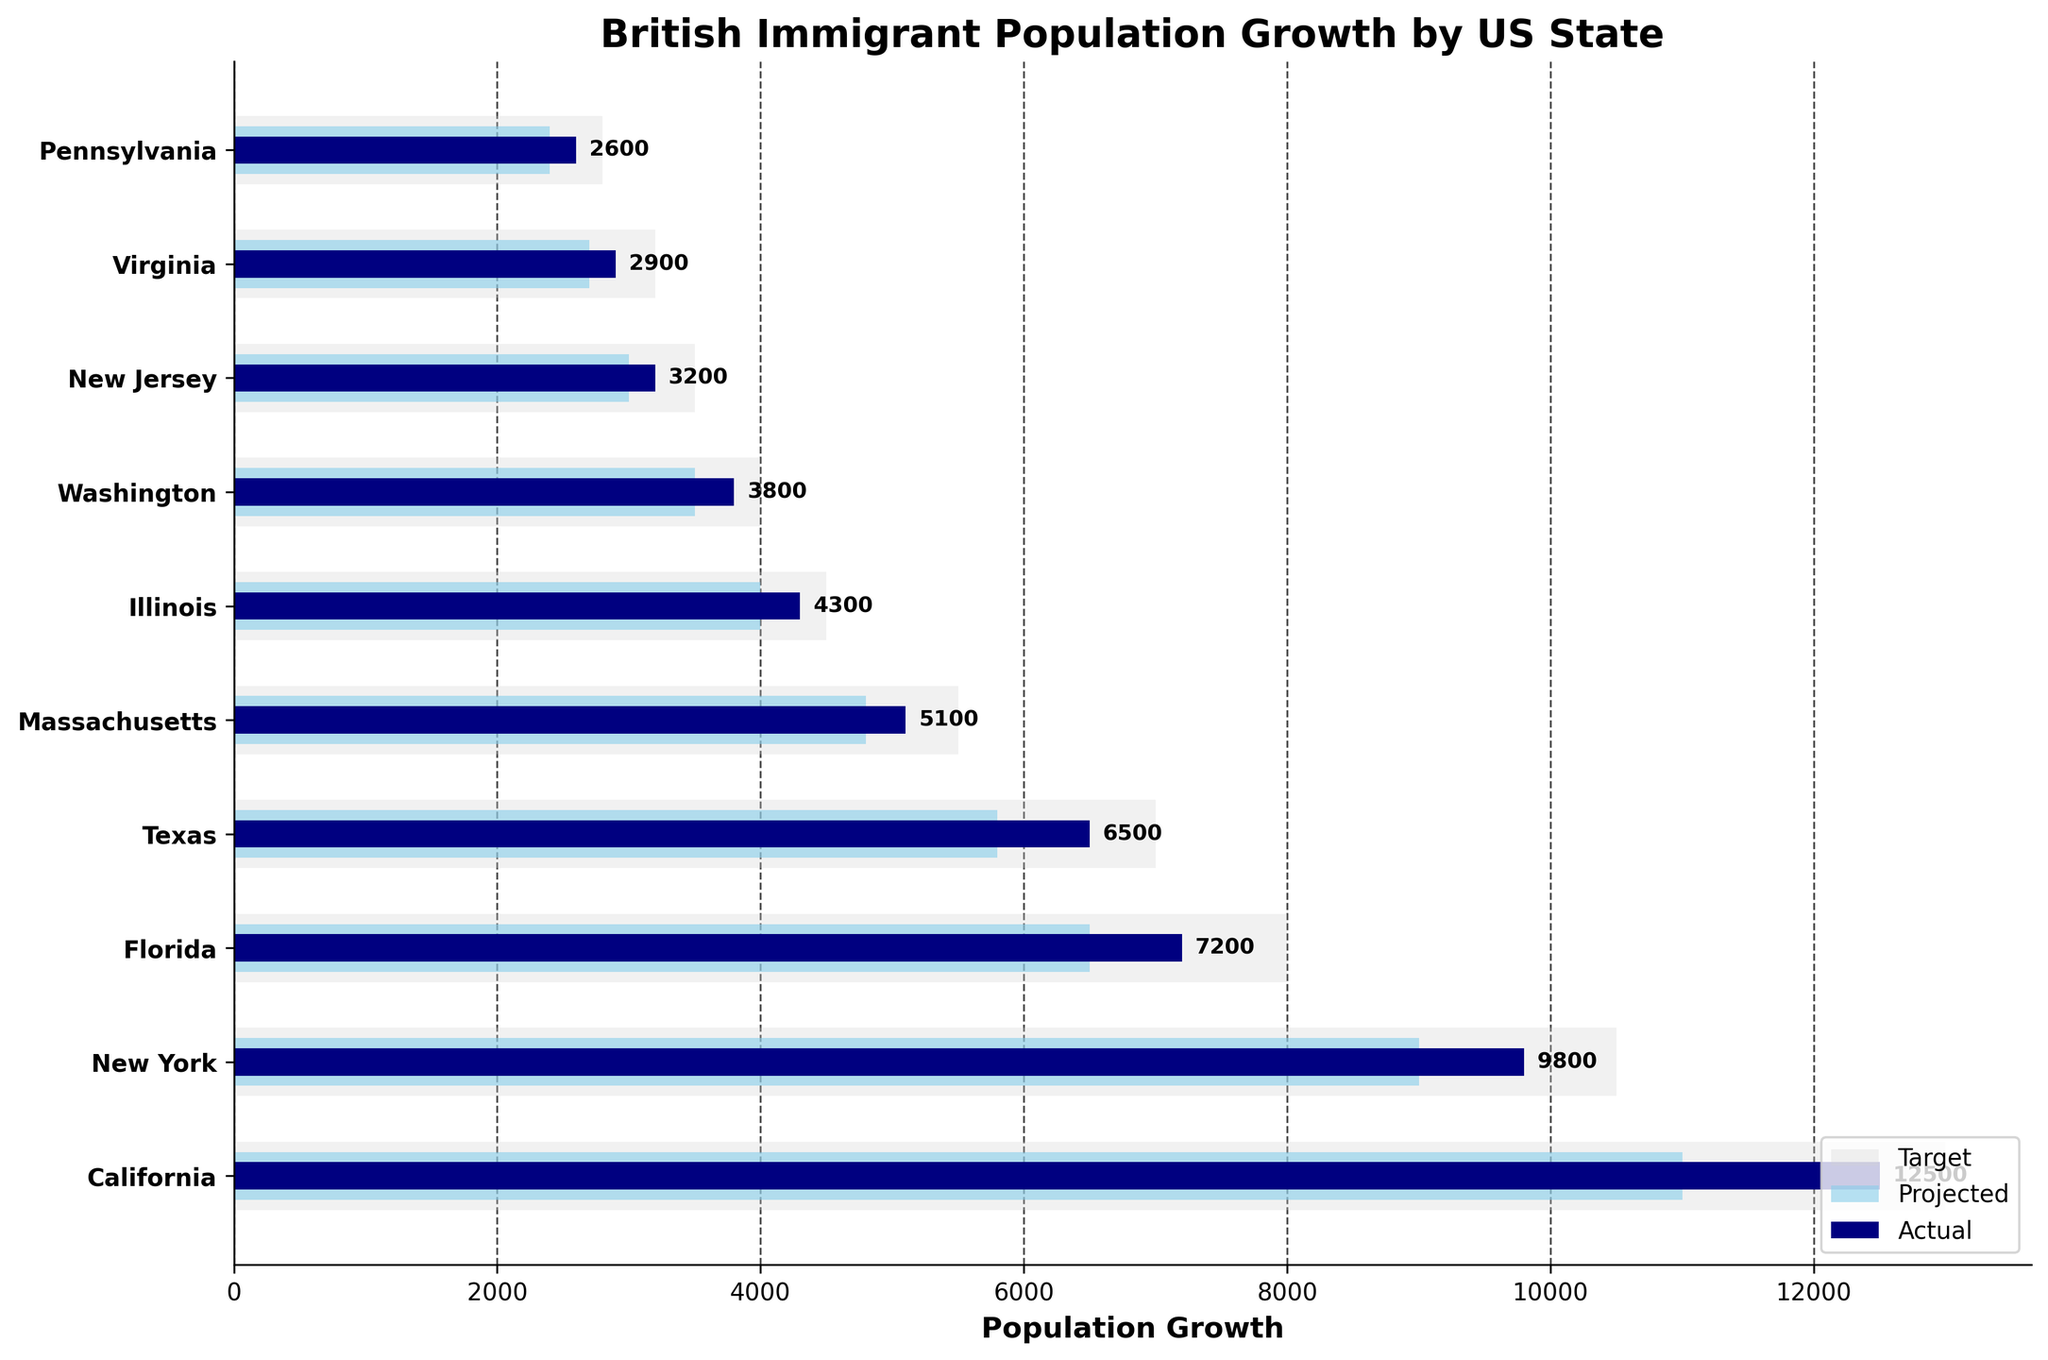What is the title of the figure? The title is located at the top of the plot. By looking at the plot's title area, we can see that it is 'British Immigrant Population Growth by US State'.
Answer: British Immigrant Population Growth by US State Which US state shows the highest actual population growth for British immigrants? The actual population growth bars are colored in navy. By looking at the length of the navy bars, the longest one corresponds to California with a value of 12,500.
Answer: California How much greater is the actual population growth compared to the projected growth in New York? The actual population growth for New York is 9,800 and the projected growth is 9,000. The difference is obtained by subtracting the projected growth from the actual growth: 9,800 - 9,000 = 800.
Answer: 800 Which US state has the smallest target growth, and what is the value? The target growth bars are colored in light grey. By comparing the lengths of all the light grey bars, the shortest belongs to Pennsylvania with a value of 2,800.
Answer: Pennsylvania; 2,800 What is the actual growth for British immigrants in Florida? The actual growth bars are in navy. By looking at the bar corresponding to Florida, we see that its value is 7,200.
Answer: 7,200 Compare the target growth in California and Texas. Which state has a higher value and by how much? The target growth for California is 13,000, and for Texas, it is 7,000. The difference is calculated as 13,000 - 7,000 = 6,000. California has a higher value by 6,000.
Answer: California; 6,000 What is the sum of the actual population growth for Massachusetts and Illinois? The actual growth for Massachusetts is 5,100 and for Illinois is 4,300. By summing these values, we get 5,100 + 4,300 = 9,400.
Answer: 9,400 If we rank the states by their actual growth values, which state ranks third? Sorting the actual growth values in descending order, the third position belongs to Florida with an actual growth of 7,200.
Answer: Florida Which state’s actual growth is closest to its projected growth? To find the state where the actual growth is closest to the projected growth, we need to compare the values for all states. The smallest difference occurs in Illinois where the actual growth is 4,300 and the projected growth is 4,000. The difference is 300.
Answer: Illinois By how much does the actual population growth in Virginia exceed its target growth? The actual growth for Virginia is 2,900 and the target growth is 3,200. Since the actual growth is less than the target growth, there is no excess. Therefore, Virginia's actual growth does not exceed its target growth.
Answer: It does not exceed 